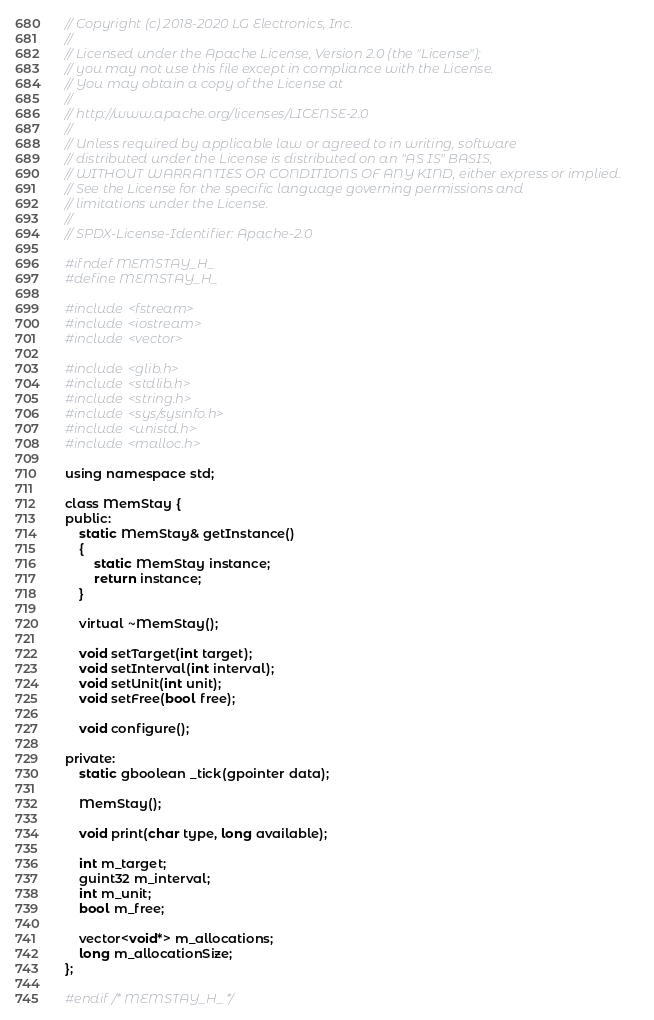Convert code to text. <code><loc_0><loc_0><loc_500><loc_500><_C_>// Copyright (c) 2018-2020 LG Electronics, Inc.
//
// Licensed under the Apache License, Version 2.0 (the "License");
// you may not use this file except in compliance with the License.
// You may obtain a copy of the License at
//
// http://www.apache.org/licenses/LICENSE-2.0
//
// Unless required by applicable law or agreed to in writing, software
// distributed under the License is distributed on an "AS IS" BASIS,
// WITHOUT WARRANTIES OR CONDITIONS OF ANY KIND, either express or implied.
// See the License for the specific language governing permissions and
// limitations under the License.
//
// SPDX-License-Identifier: Apache-2.0

#ifndef MEMSTAY_H_
#define MEMSTAY_H_

#include <fstream>
#include <iostream>
#include <vector>

#include <glib.h>
#include <stdlib.h>
#include <string.h>
#include <sys/sysinfo.h>
#include <unistd.h>
#include <malloc.h>

using namespace std;

class MemStay {
public:
    static MemStay& getInstance()
    {
        static MemStay instance;
        return instance;
    }

    virtual ~MemStay();

    void setTarget(int target);
    void setInterval(int interval);
    void setUnit(int unit);
    void setFree(bool free);

    void configure();

private:
    static gboolean _tick(gpointer data);

    MemStay();

    void print(char type, long available);

    int m_target;
    guint32 m_interval;
    int m_unit;
    bool m_free;

    vector<void*> m_allocations;
    long m_allocationSize;
};

#endif /* MEMSTAY_H_ */
</code> 